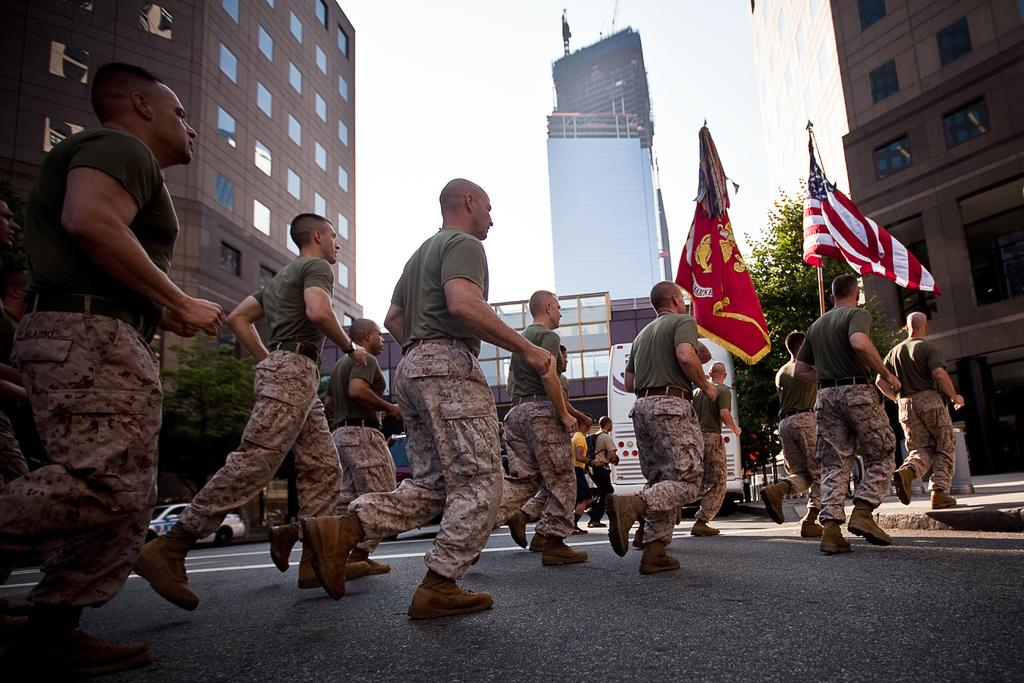What are the persons in the image wearing? The persons in the image are wearing uniforms. What are the persons with uniforms doing in the image? The persons are running on the road. What can be seen in the image besides the persons running? There are flags, buildings, vehicles, trees, and the sky visible in the image. What type of lead can be seen being used by the persons in the image? There is no lead present in the image; the persons are running on the road. What kind of plate is visible on the vehicles in the image? There are no plates visible on the vehicles in the image. 